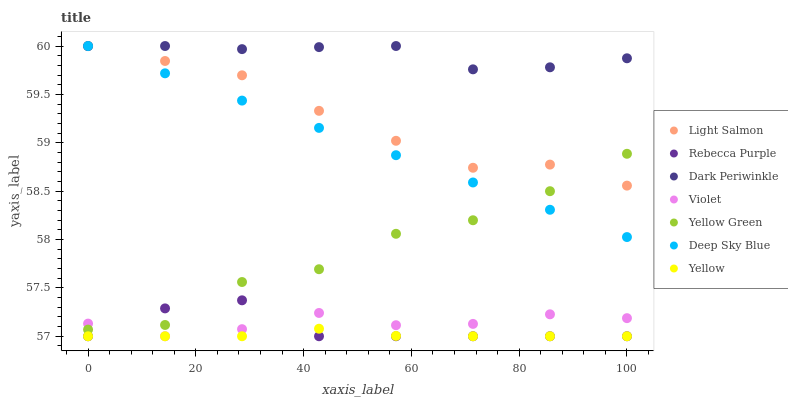Does Yellow have the minimum area under the curve?
Answer yes or no. Yes. Does Dark Periwinkle have the maximum area under the curve?
Answer yes or no. Yes. Does Yellow Green have the minimum area under the curve?
Answer yes or no. No. Does Yellow Green have the maximum area under the curve?
Answer yes or no. No. Is Deep Sky Blue the smoothest?
Answer yes or no. Yes. Is Yellow Green the roughest?
Answer yes or no. Yes. Is Yellow the smoothest?
Answer yes or no. No. Is Yellow the roughest?
Answer yes or no. No. Does Yellow have the lowest value?
Answer yes or no. Yes. Does Yellow Green have the lowest value?
Answer yes or no. No. Does Dark Periwinkle have the highest value?
Answer yes or no. Yes. Does Yellow Green have the highest value?
Answer yes or no. No. Is Yellow less than Dark Periwinkle?
Answer yes or no. Yes. Is Dark Periwinkle greater than Yellow?
Answer yes or no. Yes. Does Yellow intersect Rebecca Purple?
Answer yes or no. Yes. Is Yellow less than Rebecca Purple?
Answer yes or no. No. Is Yellow greater than Rebecca Purple?
Answer yes or no. No. Does Yellow intersect Dark Periwinkle?
Answer yes or no. No. 